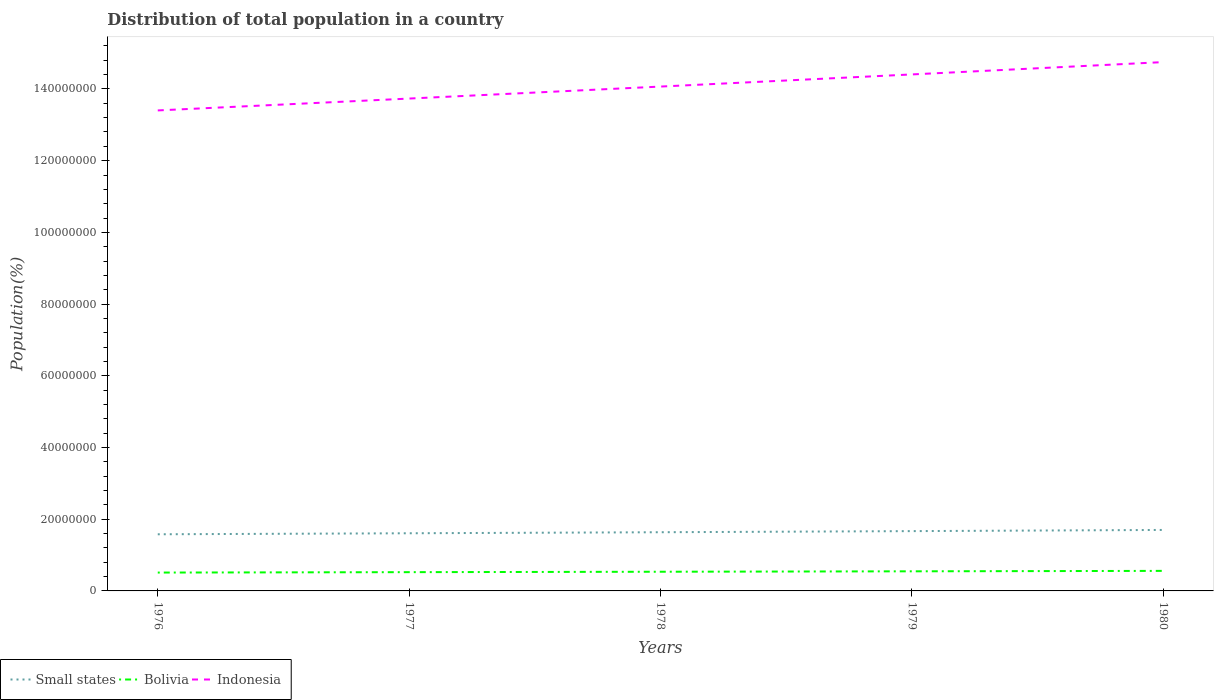How many different coloured lines are there?
Offer a terse response. 3. Is the number of lines equal to the number of legend labels?
Give a very brief answer. Yes. Across all years, what is the maximum population of in Bolivia?
Ensure brevity in your answer.  5.12e+06. In which year was the population of in Small states maximum?
Your answer should be compact. 1976. What is the total population of in Bolivia in the graph?
Your response must be concise. -3.49e+05. What is the difference between the highest and the second highest population of in Small states?
Provide a succinct answer. 1.21e+06. What is the difference between the highest and the lowest population of in Indonesia?
Your answer should be very brief. 2. How many lines are there?
Provide a succinct answer. 3. How many years are there in the graph?
Give a very brief answer. 5. Are the values on the major ticks of Y-axis written in scientific E-notation?
Offer a very short reply. No. Does the graph contain any zero values?
Provide a succinct answer. No. How are the legend labels stacked?
Offer a very short reply. Horizontal. What is the title of the graph?
Make the answer very short. Distribution of total population in a country. What is the label or title of the Y-axis?
Your response must be concise. Population(%). What is the Population(%) of Small states in 1976?
Ensure brevity in your answer.  1.58e+07. What is the Population(%) in Bolivia in 1976?
Make the answer very short. 5.12e+06. What is the Population(%) in Indonesia in 1976?
Make the answer very short. 1.34e+08. What is the Population(%) in Small states in 1977?
Ensure brevity in your answer.  1.61e+07. What is the Population(%) of Bolivia in 1977?
Your response must be concise. 5.23e+06. What is the Population(%) in Indonesia in 1977?
Give a very brief answer. 1.37e+08. What is the Population(%) of Small states in 1978?
Your response must be concise. 1.64e+07. What is the Population(%) in Bolivia in 1978?
Your answer should be very brief. 5.35e+06. What is the Population(%) in Indonesia in 1978?
Your response must be concise. 1.41e+08. What is the Population(%) of Small states in 1979?
Provide a succinct answer. 1.67e+07. What is the Population(%) in Bolivia in 1979?
Offer a terse response. 5.47e+06. What is the Population(%) of Indonesia in 1979?
Your answer should be very brief. 1.44e+08. What is the Population(%) in Small states in 1980?
Provide a succinct answer. 1.70e+07. What is the Population(%) in Bolivia in 1980?
Make the answer very short. 5.59e+06. What is the Population(%) in Indonesia in 1980?
Ensure brevity in your answer.  1.47e+08. Across all years, what is the maximum Population(%) in Small states?
Give a very brief answer. 1.70e+07. Across all years, what is the maximum Population(%) of Bolivia?
Your answer should be very brief. 5.59e+06. Across all years, what is the maximum Population(%) of Indonesia?
Your answer should be compact. 1.47e+08. Across all years, what is the minimum Population(%) in Small states?
Make the answer very short. 1.58e+07. Across all years, what is the minimum Population(%) in Bolivia?
Make the answer very short. 5.12e+06. Across all years, what is the minimum Population(%) of Indonesia?
Provide a short and direct response. 1.34e+08. What is the total Population(%) in Small states in the graph?
Offer a terse response. 8.19e+07. What is the total Population(%) in Bolivia in the graph?
Provide a succinct answer. 2.68e+07. What is the total Population(%) in Indonesia in the graph?
Provide a short and direct response. 7.04e+08. What is the difference between the Population(%) of Small states in 1976 and that in 1977?
Offer a terse response. -2.84e+05. What is the difference between the Population(%) of Bolivia in 1976 and that in 1977?
Make the answer very short. -1.14e+05. What is the difference between the Population(%) of Indonesia in 1976 and that in 1977?
Keep it short and to the point. -3.31e+06. What is the difference between the Population(%) in Small states in 1976 and that in 1978?
Ensure brevity in your answer.  -5.73e+05. What is the difference between the Population(%) in Bolivia in 1976 and that in 1978?
Provide a succinct answer. -2.30e+05. What is the difference between the Population(%) of Indonesia in 1976 and that in 1978?
Offer a terse response. -6.66e+06. What is the difference between the Population(%) in Small states in 1976 and that in 1979?
Your response must be concise. -8.82e+05. What is the difference between the Population(%) in Bolivia in 1976 and that in 1979?
Offer a terse response. -3.49e+05. What is the difference between the Population(%) of Indonesia in 1976 and that in 1979?
Provide a succinct answer. -1.00e+07. What is the difference between the Population(%) in Small states in 1976 and that in 1980?
Keep it short and to the point. -1.21e+06. What is the difference between the Population(%) in Bolivia in 1976 and that in 1980?
Provide a short and direct response. -4.70e+05. What is the difference between the Population(%) in Indonesia in 1976 and that in 1980?
Offer a terse response. -1.35e+07. What is the difference between the Population(%) of Small states in 1977 and that in 1978?
Offer a very short reply. -2.89e+05. What is the difference between the Population(%) in Bolivia in 1977 and that in 1978?
Offer a very short reply. -1.17e+05. What is the difference between the Population(%) in Indonesia in 1977 and that in 1978?
Your answer should be compact. -3.34e+06. What is the difference between the Population(%) in Small states in 1977 and that in 1979?
Offer a terse response. -5.98e+05. What is the difference between the Population(%) in Bolivia in 1977 and that in 1979?
Your response must be concise. -2.35e+05. What is the difference between the Population(%) in Indonesia in 1977 and that in 1979?
Give a very brief answer. -6.73e+06. What is the difference between the Population(%) of Small states in 1977 and that in 1980?
Your response must be concise. -9.27e+05. What is the difference between the Population(%) in Bolivia in 1977 and that in 1980?
Your answer should be compact. -3.56e+05. What is the difference between the Population(%) in Indonesia in 1977 and that in 1980?
Your response must be concise. -1.02e+07. What is the difference between the Population(%) of Small states in 1978 and that in 1979?
Your response must be concise. -3.09e+05. What is the difference between the Population(%) in Bolivia in 1978 and that in 1979?
Provide a succinct answer. -1.19e+05. What is the difference between the Population(%) in Indonesia in 1978 and that in 1979?
Provide a succinct answer. -3.39e+06. What is the difference between the Population(%) of Small states in 1978 and that in 1980?
Your response must be concise. -6.38e+05. What is the difference between the Population(%) in Bolivia in 1978 and that in 1980?
Offer a very short reply. -2.39e+05. What is the difference between the Population(%) in Indonesia in 1978 and that in 1980?
Give a very brief answer. -6.82e+06. What is the difference between the Population(%) in Small states in 1979 and that in 1980?
Your answer should be compact. -3.29e+05. What is the difference between the Population(%) of Bolivia in 1979 and that in 1980?
Give a very brief answer. -1.20e+05. What is the difference between the Population(%) in Indonesia in 1979 and that in 1980?
Offer a very short reply. -3.44e+06. What is the difference between the Population(%) of Small states in 1976 and the Population(%) of Bolivia in 1977?
Make the answer very short. 1.06e+07. What is the difference between the Population(%) in Small states in 1976 and the Population(%) in Indonesia in 1977?
Give a very brief answer. -1.22e+08. What is the difference between the Population(%) in Bolivia in 1976 and the Population(%) in Indonesia in 1977?
Provide a short and direct response. -1.32e+08. What is the difference between the Population(%) of Small states in 1976 and the Population(%) of Bolivia in 1978?
Provide a short and direct response. 1.04e+07. What is the difference between the Population(%) of Small states in 1976 and the Population(%) of Indonesia in 1978?
Keep it short and to the point. -1.25e+08. What is the difference between the Population(%) of Bolivia in 1976 and the Population(%) of Indonesia in 1978?
Give a very brief answer. -1.36e+08. What is the difference between the Population(%) of Small states in 1976 and the Population(%) of Bolivia in 1979?
Your response must be concise. 1.03e+07. What is the difference between the Population(%) of Small states in 1976 and the Population(%) of Indonesia in 1979?
Your response must be concise. -1.28e+08. What is the difference between the Population(%) in Bolivia in 1976 and the Population(%) in Indonesia in 1979?
Offer a terse response. -1.39e+08. What is the difference between the Population(%) in Small states in 1976 and the Population(%) in Bolivia in 1980?
Give a very brief answer. 1.02e+07. What is the difference between the Population(%) in Small states in 1976 and the Population(%) in Indonesia in 1980?
Offer a very short reply. -1.32e+08. What is the difference between the Population(%) of Bolivia in 1976 and the Population(%) of Indonesia in 1980?
Give a very brief answer. -1.42e+08. What is the difference between the Population(%) in Small states in 1977 and the Population(%) in Bolivia in 1978?
Offer a terse response. 1.07e+07. What is the difference between the Population(%) of Small states in 1977 and the Population(%) of Indonesia in 1978?
Keep it short and to the point. -1.25e+08. What is the difference between the Population(%) in Bolivia in 1977 and the Population(%) in Indonesia in 1978?
Your answer should be compact. -1.35e+08. What is the difference between the Population(%) of Small states in 1977 and the Population(%) of Bolivia in 1979?
Provide a short and direct response. 1.06e+07. What is the difference between the Population(%) of Small states in 1977 and the Population(%) of Indonesia in 1979?
Make the answer very short. -1.28e+08. What is the difference between the Population(%) in Bolivia in 1977 and the Population(%) in Indonesia in 1979?
Keep it short and to the point. -1.39e+08. What is the difference between the Population(%) of Small states in 1977 and the Population(%) of Bolivia in 1980?
Keep it short and to the point. 1.05e+07. What is the difference between the Population(%) of Small states in 1977 and the Population(%) of Indonesia in 1980?
Your answer should be compact. -1.31e+08. What is the difference between the Population(%) in Bolivia in 1977 and the Population(%) in Indonesia in 1980?
Your answer should be compact. -1.42e+08. What is the difference between the Population(%) in Small states in 1978 and the Population(%) in Bolivia in 1979?
Offer a terse response. 1.09e+07. What is the difference between the Population(%) in Small states in 1978 and the Population(%) in Indonesia in 1979?
Ensure brevity in your answer.  -1.28e+08. What is the difference between the Population(%) of Bolivia in 1978 and the Population(%) of Indonesia in 1979?
Keep it short and to the point. -1.39e+08. What is the difference between the Population(%) of Small states in 1978 and the Population(%) of Bolivia in 1980?
Provide a short and direct response. 1.08e+07. What is the difference between the Population(%) of Small states in 1978 and the Population(%) of Indonesia in 1980?
Offer a very short reply. -1.31e+08. What is the difference between the Population(%) of Bolivia in 1978 and the Population(%) of Indonesia in 1980?
Make the answer very short. -1.42e+08. What is the difference between the Population(%) in Small states in 1979 and the Population(%) in Bolivia in 1980?
Your answer should be very brief. 1.11e+07. What is the difference between the Population(%) of Small states in 1979 and the Population(%) of Indonesia in 1980?
Make the answer very short. -1.31e+08. What is the difference between the Population(%) of Bolivia in 1979 and the Population(%) of Indonesia in 1980?
Keep it short and to the point. -1.42e+08. What is the average Population(%) in Small states per year?
Your answer should be compact. 1.64e+07. What is the average Population(%) of Bolivia per year?
Ensure brevity in your answer.  5.35e+06. What is the average Population(%) of Indonesia per year?
Keep it short and to the point. 1.41e+08. In the year 1976, what is the difference between the Population(%) in Small states and Population(%) in Bolivia?
Ensure brevity in your answer.  1.07e+07. In the year 1976, what is the difference between the Population(%) in Small states and Population(%) in Indonesia?
Ensure brevity in your answer.  -1.18e+08. In the year 1976, what is the difference between the Population(%) in Bolivia and Population(%) in Indonesia?
Your answer should be very brief. -1.29e+08. In the year 1977, what is the difference between the Population(%) in Small states and Population(%) in Bolivia?
Ensure brevity in your answer.  1.08e+07. In the year 1977, what is the difference between the Population(%) of Small states and Population(%) of Indonesia?
Provide a short and direct response. -1.21e+08. In the year 1977, what is the difference between the Population(%) in Bolivia and Population(%) in Indonesia?
Provide a short and direct response. -1.32e+08. In the year 1978, what is the difference between the Population(%) of Small states and Population(%) of Bolivia?
Make the answer very short. 1.10e+07. In the year 1978, what is the difference between the Population(%) in Small states and Population(%) in Indonesia?
Your answer should be compact. -1.24e+08. In the year 1978, what is the difference between the Population(%) in Bolivia and Population(%) in Indonesia?
Your response must be concise. -1.35e+08. In the year 1979, what is the difference between the Population(%) in Small states and Population(%) in Bolivia?
Offer a very short reply. 1.12e+07. In the year 1979, what is the difference between the Population(%) of Small states and Population(%) of Indonesia?
Your answer should be very brief. -1.27e+08. In the year 1979, what is the difference between the Population(%) in Bolivia and Population(%) in Indonesia?
Offer a terse response. -1.39e+08. In the year 1980, what is the difference between the Population(%) of Small states and Population(%) of Bolivia?
Your response must be concise. 1.14e+07. In the year 1980, what is the difference between the Population(%) in Small states and Population(%) in Indonesia?
Provide a succinct answer. -1.30e+08. In the year 1980, what is the difference between the Population(%) in Bolivia and Population(%) in Indonesia?
Give a very brief answer. -1.42e+08. What is the ratio of the Population(%) in Small states in 1976 to that in 1977?
Offer a very short reply. 0.98. What is the ratio of the Population(%) in Bolivia in 1976 to that in 1977?
Make the answer very short. 0.98. What is the ratio of the Population(%) in Indonesia in 1976 to that in 1977?
Give a very brief answer. 0.98. What is the ratio of the Population(%) of Small states in 1976 to that in 1978?
Offer a terse response. 0.96. What is the ratio of the Population(%) in Bolivia in 1976 to that in 1978?
Make the answer very short. 0.96. What is the ratio of the Population(%) in Indonesia in 1976 to that in 1978?
Keep it short and to the point. 0.95. What is the ratio of the Population(%) in Small states in 1976 to that in 1979?
Provide a short and direct response. 0.95. What is the ratio of the Population(%) of Bolivia in 1976 to that in 1979?
Provide a short and direct response. 0.94. What is the ratio of the Population(%) of Indonesia in 1976 to that in 1979?
Keep it short and to the point. 0.93. What is the ratio of the Population(%) in Small states in 1976 to that in 1980?
Keep it short and to the point. 0.93. What is the ratio of the Population(%) in Bolivia in 1976 to that in 1980?
Give a very brief answer. 0.92. What is the ratio of the Population(%) of Indonesia in 1976 to that in 1980?
Make the answer very short. 0.91. What is the ratio of the Population(%) in Small states in 1977 to that in 1978?
Provide a short and direct response. 0.98. What is the ratio of the Population(%) of Bolivia in 1977 to that in 1978?
Offer a terse response. 0.98. What is the ratio of the Population(%) in Indonesia in 1977 to that in 1978?
Make the answer very short. 0.98. What is the ratio of the Population(%) of Small states in 1977 to that in 1979?
Your answer should be very brief. 0.96. What is the ratio of the Population(%) of Bolivia in 1977 to that in 1979?
Your answer should be compact. 0.96. What is the ratio of the Population(%) of Indonesia in 1977 to that in 1979?
Your response must be concise. 0.95. What is the ratio of the Population(%) in Small states in 1977 to that in 1980?
Offer a terse response. 0.95. What is the ratio of the Population(%) of Bolivia in 1977 to that in 1980?
Your answer should be compact. 0.94. What is the ratio of the Population(%) of Indonesia in 1977 to that in 1980?
Provide a short and direct response. 0.93. What is the ratio of the Population(%) in Small states in 1978 to that in 1979?
Give a very brief answer. 0.98. What is the ratio of the Population(%) in Bolivia in 1978 to that in 1979?
Ensure brevity in your answer.  0.98. What is the ratio of the Population(%) in Indonesia in 1978 to that in 1979?
Provide a succinct answer. 0.98. What is the ratio of the Population(%) in Small states in 1978 to that in 1980?
Offer a very short reply. 0.96. What is the ratio of the Population(%) of Bolivia in 1978 to that in 1980?
Provide a short and direct response. 0.96. What is the ratio of the Population(%) in Indonesia in 1978 to that in 1980?
Give a very brief answer. 0.95. What is the ratio of the Population(%) in Small states in 1979 to that in 1980?
Ensure brevity in your answer.  0.98. What is the ratio of the Population(%) of Bolivia in 1979 to that in 1980?
Provide a succinct answer. 0.98. What is the ratio of the Population(%) of Indonesia in 1979 to that in 1980?
Your answer should be compact. 0.98. What is the difference between the highest and the second highest Population(%) of Small states?
Offer a terse response. 3.29e+05. What is the difference between the highest and the second highest Population(%) in Bolivia?
Offer a very short reply. 1.20e+05. What is the difference between the highest and the second highest Population(%) in Indonesia?
Give a very brief answer. 3.44e+06. What is the difference between the highest and the lowest Population(%) of Small states?
Your answer should be compact. 1.21e+06. What is the difference between the highest and the lowest Population(%) of Bolivia?
Offer a terse response. 4.70e+05. What is the difference between the highest and the lowest Population(%) in Indonesia?
Keep it short and to the point. 1.35e+07. 